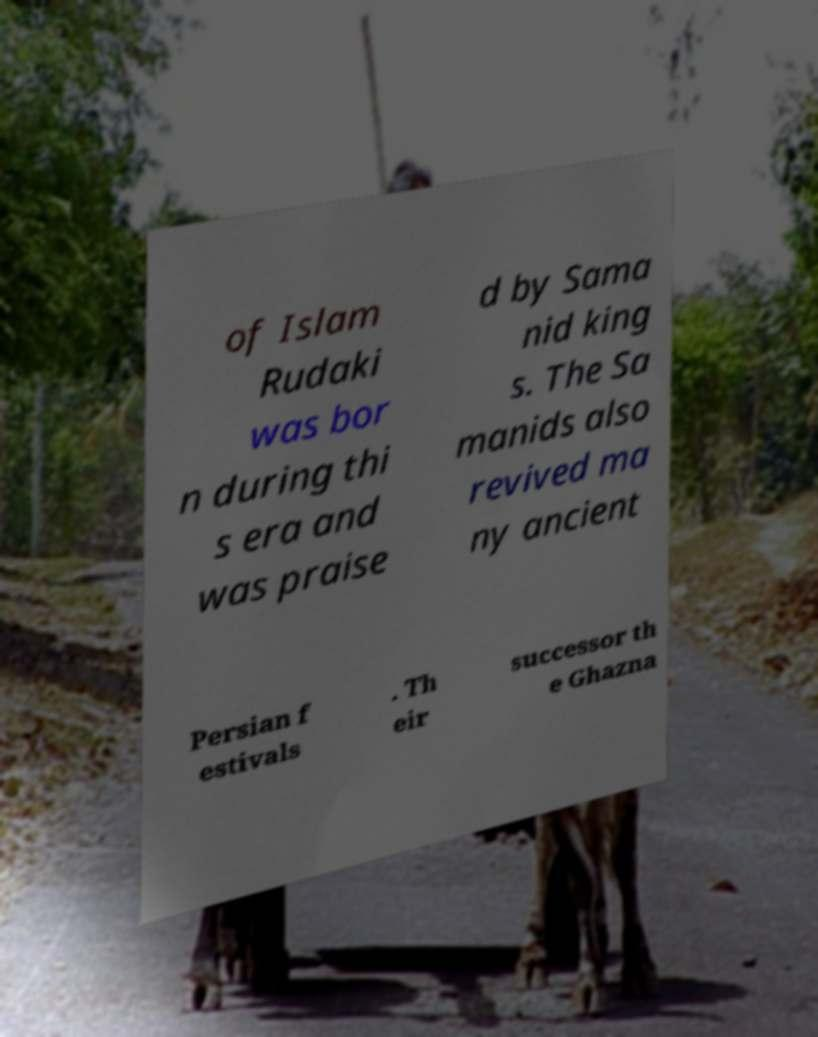Can you accurately transcribe the text from the provided image for me? of Islam Rudaki was bor n during thi s era and was praise d by Sama nid king s. The Sa manids also revived ma ny ancient Persian f estivals . Th eir successor th e Ghazna 